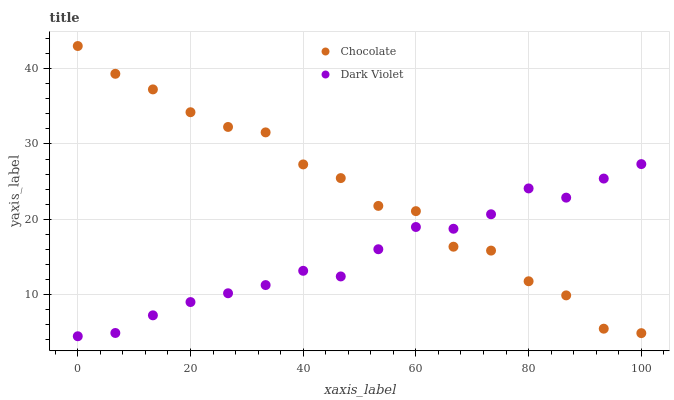Does Dark Violet have the minimum area under the curve?
Answer yes or no. Yes. Does Chocolate have the maximum area under the curve?
Answer yes or no. Yes. Does Chocolate have the minimum area under the curve?
Answer yes or no. No. Is Dark Violet the smoothest?
Answer yes or no. Yes. Is Chocolate the roughest?
Answer yes or no. Yes. Is Chocolate the smoothest?
Answer yes or no. No. Does Dark Violet have the lowest value?
Answer yes or no. Yes. Does Chocolate have the lowest value?
Answer yes or no. No. Does Chocolate have the highest value?
Answer yes or no. Yes. Does Chocolate intersect Dark Violet?
Answer yes or no. Yes. Is Chocolate less than Dark Violet?
Answer yes or no. No. Is Chocolate greater than Dark Violet?
Answer yes or no. No. 